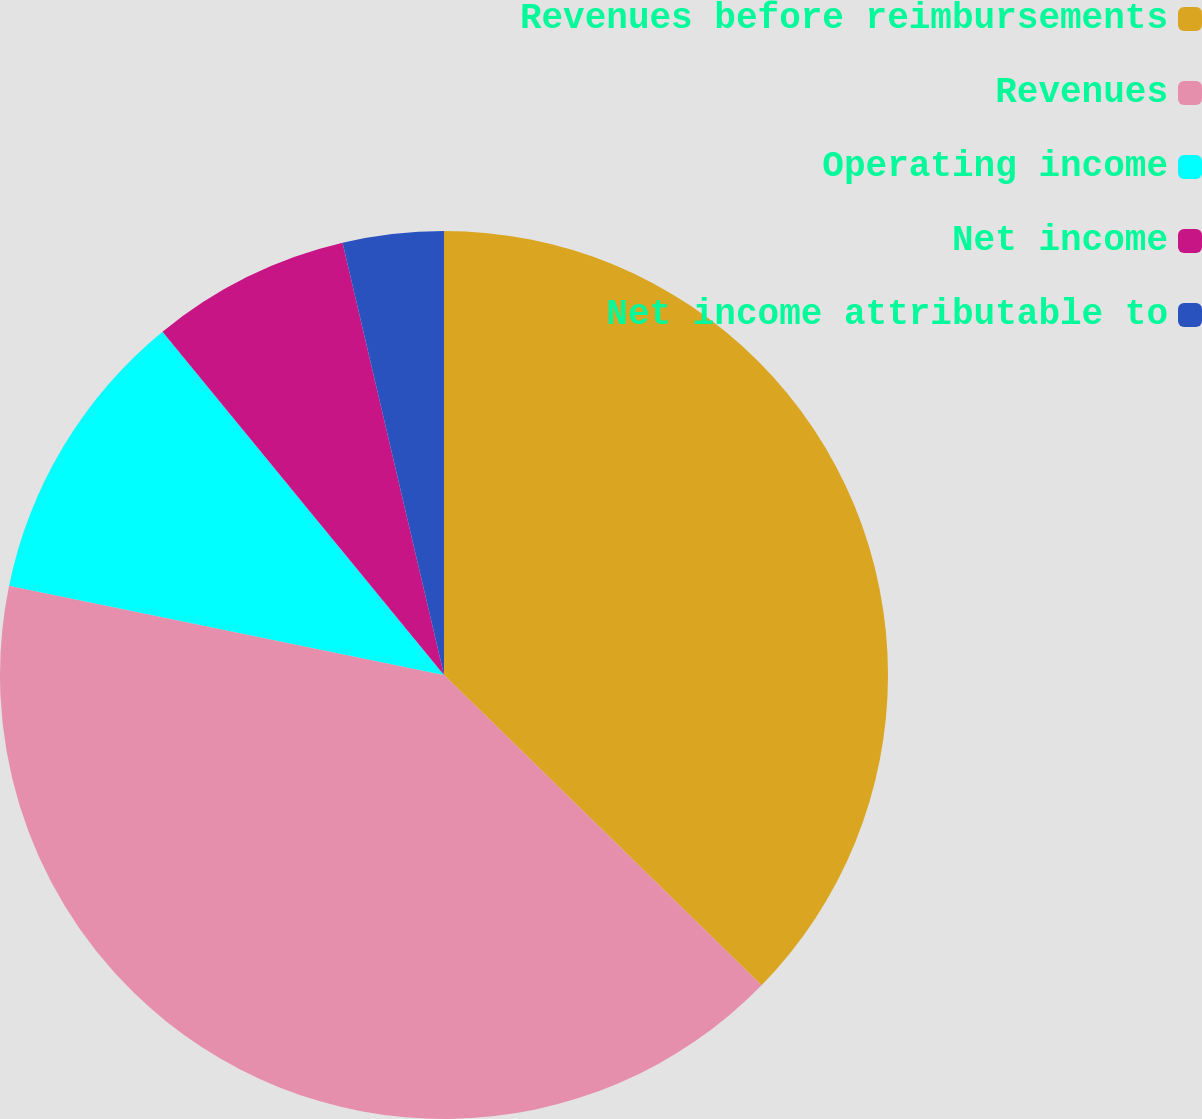Convert chart to OTSL. <chart><loc_0><loc_0><loc_500><loc_500><pie_chart><fcel>Revenues before reimbursements<fcel>Revenues<fcel>Operating income<fcel>Net income<fcel>Net income attributable to<nl><fcel>37.32%<fcel>40.91%<fcel>10.85%<fcel>7.26%<fcel>3.67%<nl></chart> 